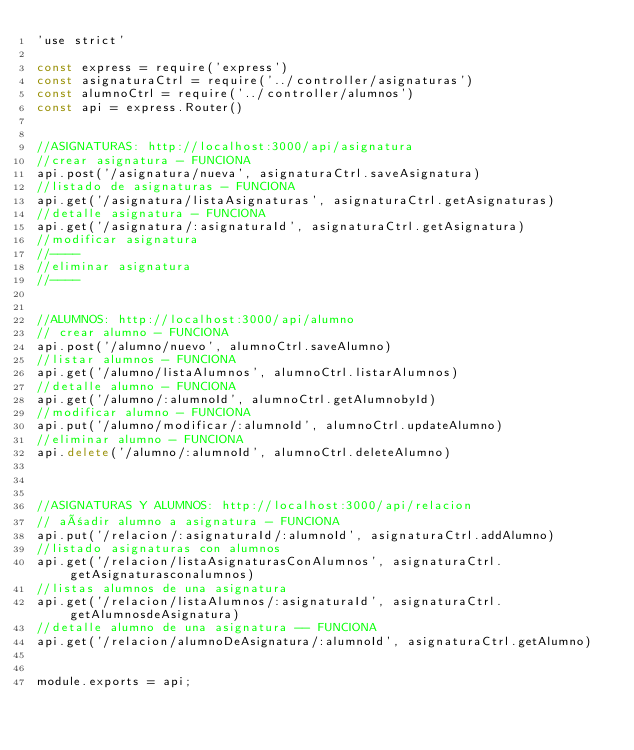<code> <loc_0><loc_0><loc_500><loc_500><_JavaScript_>'use strict'

const express = require('express')
const asignaturaCtrl = require('../controller/asignaturas')
const alumnoCtrl = require('../controller/alumnos')
const api = express.Router()


//ASIGNATURAS: http://localhost:3000/api/asignatura
//crear asignatura - FUNCIONA
api.post('/asignatura/nueva', asignaturaCtrl.saveAsignatura)
//listado de asignaturas - FUNCIONA
api.get('/asignatura/listaAsignaturas', asignaturaCtrl.getAsignaturas)
//detalle asignatura - FUNCIONA
api.get('/asignatura/:asignaturaId', asignaturaCtrl.getAsignatura)
//modificar asignatura
//----
//eliminar asignatura
//----


//ALUMNOS: http://localhost:3000/api/alumno
// crear alumno - FUNCIONA
api.post('/alumno/nuevo', alumnoCtrl.saveAlumno)
//listar alumnos - FUNCIONA
api.get('/alumno/listaAlumnos', alumnoCtrl.listarAlumnos)
//detalle alumno - FUNCIONA
api.get('/alumno/:alumnoId', alumnoCtrl.getAlumnobyId)
//modificar alumno - FUNCIONA
api.put('/alumno/modificar/:alumnoId', alumnoCtrl.updateAlumno)
//eliminar alumno - FUNCIONA
api.delete('/alumno/:alumnoId', alumnoCtrl.deleteAlumno)



//ASIGNATURAS Y ALUMNOS: http://localhost:3000/api/relacion
// añadir alumno a asignatura - FUNCIONA
api.put('/relacion/:asignaturaId/:alumnoId', asignaturaCtrl.addAlumno)
//listado asignaturas con alumnos
api.get('/relacion/listaAsignaturasConAlumnos', asignaturaCtrl.getAsignaturasconalumnos)
//listas alumnos de una asignatura
api.get('/relacion/listaAlumnos/:asignaturaId', asignaturaCtrl.getAlumnosdeAsignatura)
//detalle alumno de una asignatura -- FUNCIONA
api.get('/relacion/alumnoDeAsignatura/:alumnoId', asignaturaCtrl.getAlumno)


module.exports = api;</code> 